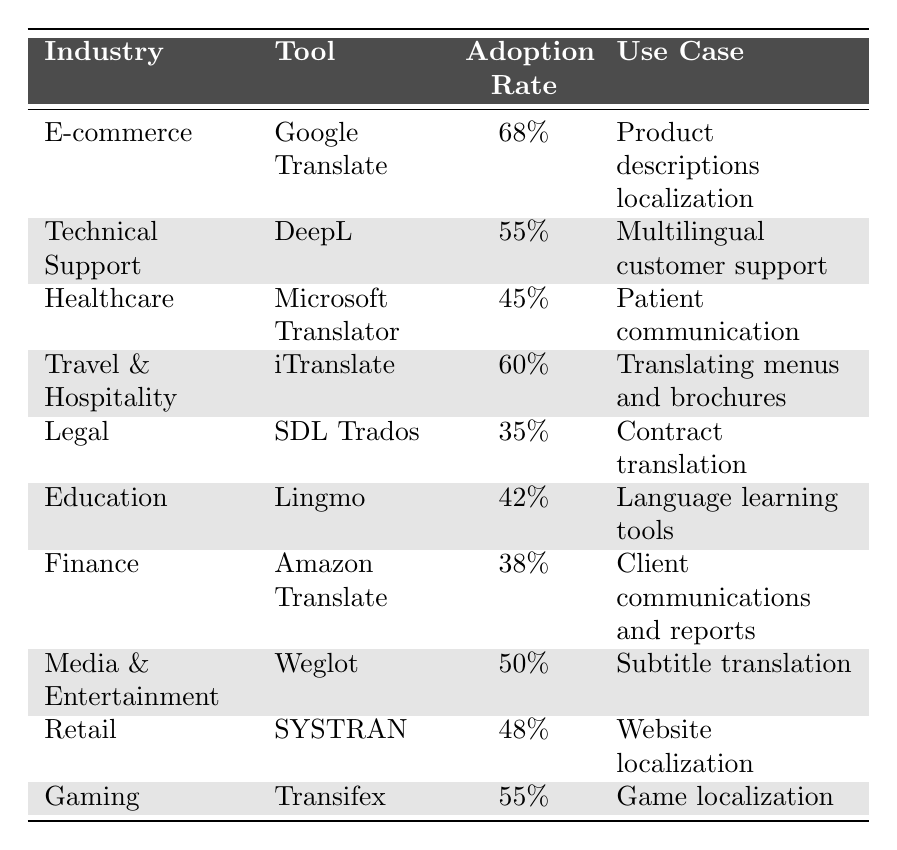What is the highest user adoption rate for a machine translation tool in 2022? The table shows various adoption rates for different industries. Scanning through the "Adoption Rate" column, Google Translate in the E-commerce industry has the highest rate at 68%.
Answer: 68% Which tool is used for multilingual customer support in the Technical Support industry? The table lists DeepL as the tool under the Technical Support industry with a usage for multilingual customer support.
Answer: DeepL What is the adoption rate of Microsoft Translator in the Healthcare sector? The table shows that Microsoft Translator has an adoption rate of 45% specifically for the Healthcare industry.
Answer: 45% Which industry has the lowest adoption rate for machine translation tools? By looking at the "Adoption Rate" values, SDL Trados in the Legal industry has the lowest rate at 35%.
Answer: 35% What is the average adoption rate for machine translation tools across the listed industries? To calculate the average, add up the adoption rates: (68% + 55% + 45% + 60% + 35% + 42% + 38% + 50% + 48% + 55%) =  497%. This total divided by 10 industries (497% / 10) equals 49.7%.
Answer: 49.7% Is iTranslate used for website localization in any industry? Checking the table reveals iTranslate has an adoption rate of 60% for the Travel & Hospitality industry, specifically for translating menus and brochures, not for website localization.
Answer: No What is the combined adoption rate of tools used in both the E-commerce and Retail industries? The adoption rates for E-commerce (Google Translate: 68%) and Retail (SYSTRAN: 48%) are combined: 68% + 48% = 116%.
Answer: 116% Which two tools have an adoption rate of 55%? From the table, both DeepL (Technical Support) and Transifex (Gaming) have an adoption rate of 55%.
Answer: DeepL and Transifex How does the adoption rate of Amazon Translate in Finance compare to that of Microsoft Translator in Healthcare? Amazon Translate has an adoption rate of 38% in Finance while Microsoft Translator has 45% in Healthcare. Comparing the two: 38% is lower than 45%.
Answer: Lower What percentage of industries use tools with an adoption rate of 50% or higher? There are 4 industries with adoption rates 50% or more: E-commerce (68%), Travel & Hospitality (60%), Gaming (55%) and DeepL (55%). Thus, 4 out of 10 industries use tools with rates of 50% or higher, which equals 40%.
Answer: 40% Is the adoption rate for translation tools in E-commerce significantly higher than in Legal? E-commerce has an adoption rate of 68%, while Legal has 35%. The difference is 68% - 35% = 33%, indicating a significant difference.
Answer: Yes 